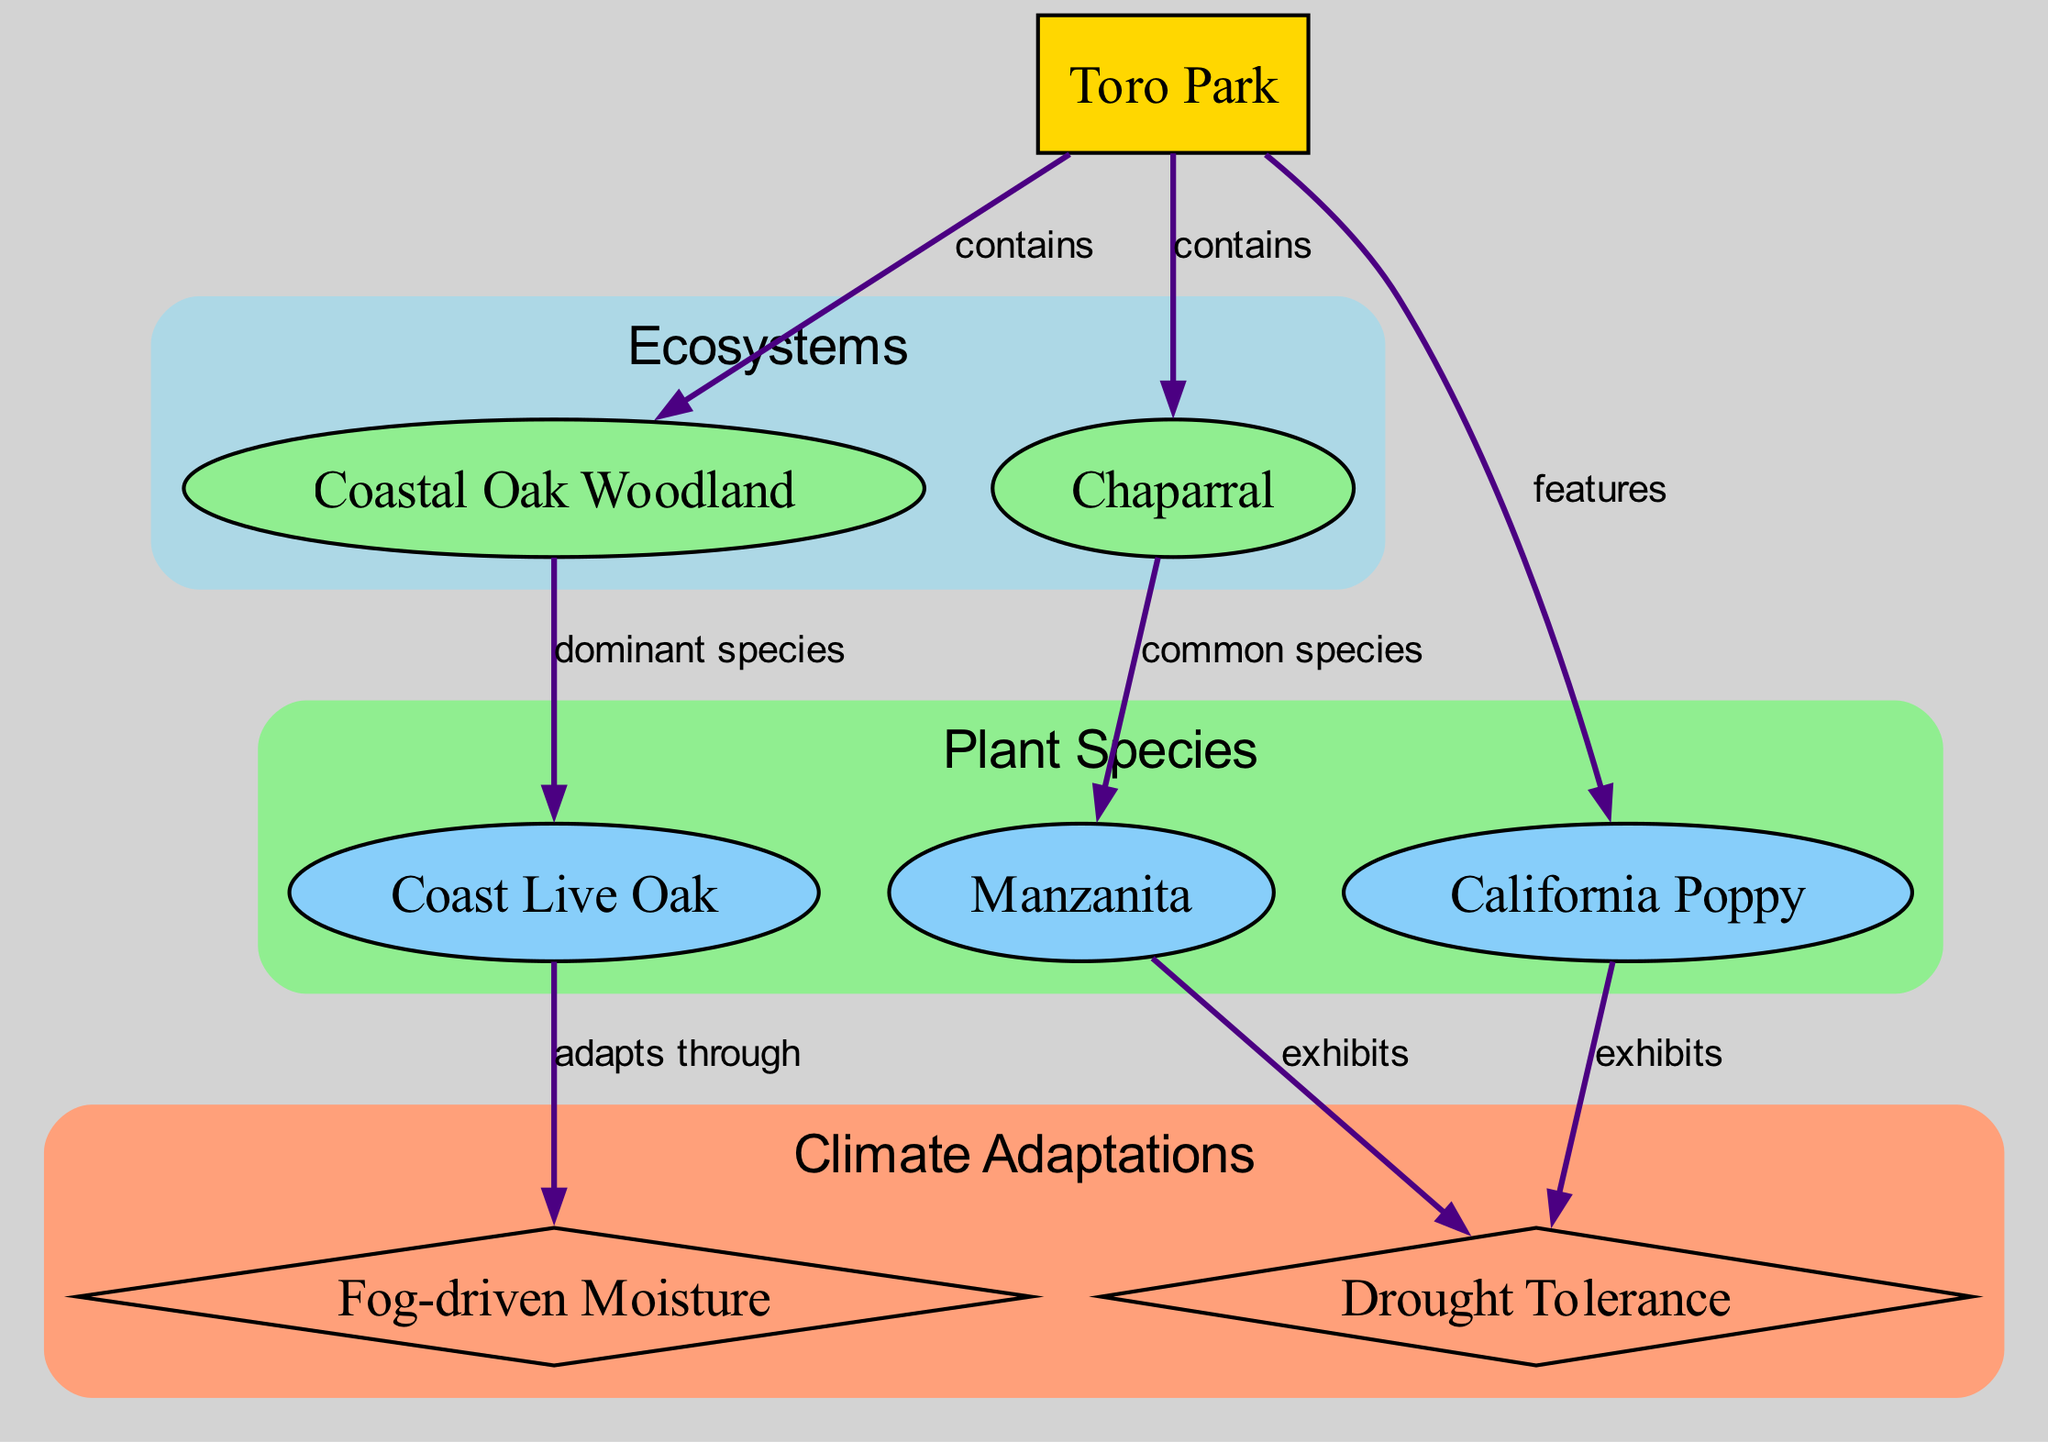What ecosystems are found in Toro Park? The diagram shows two ecosystems under the location "Toro Park": Coastal Oak Woodland and Chaparral. These ecosystems are connected to Toro Park with a "contains" relationship.
Answer: Coastal Oak Woodland, Chaparral Which is the dominant plant species in the Coastal Oak Woodland? According to the diagram, the edge indicates that the Coast Live Oak is the dominant species in the Coastal Oak Woodland ecosystem.
Answer: Coast Live Oak How many plant species are featured in Toro Park? The diagram lists three plant species: Coast Live Oak, Manzanita, and California Poppy. Counting these gives a total of three.
Answer: 3 What type of climate adaptation does the Coast Live Oak exhibit? The diagram shows that the Coast Live Oak adapts to the climate through fog-driven moisture, as indicated by the edge connected to the climate adaptation node.
Answer: Fog-driven Moisture Which plant species exhibit drought tolerance? The diagram connects both Manzanita and California Poppy to the climate adaptation "Drought Tolerance," indicating that these two plant species exhibit this adaptation.
Answer: Manzanita, California Poppy 